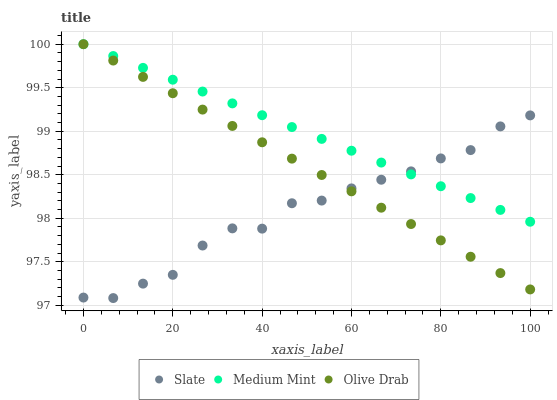Does Slate have the minimum area under the curve?
Answer yes or no. Yes. Does Medium Mint have the maximum area under the curve?
Answer yes or no. Yes. Does Olive Drab have the minimum area under the curve?
Answer yes or no. No. Does Olive Drab have the maximum area under the curve?
Answer yes or no. No. Is Olive Drab the smoothest?
Answer yes or no. Yes. Is Slate the roughest?
Answer yes or no. Yes. Is Slate the smoothest?
Answer yes or no. No. Is Olive Drab the roughest?
Answer yes or no. No. Does Slate have the lowest value?
Answer yes or no. Yes. Does Olive Drab have the lowest value?
Answer yes or no. No. Does Olive Drab have the highest value?
Answer yes or no. Yes. Does Slate have the highest value?
Answer yes or no. No. Does Medium Mint intersect Slate?
Answer yes or no. Yes. Is Medium Mint less than Slate?
Answer yes or no. No. Is Medium Mint greater than Slate?
Answer yes or no. No. 